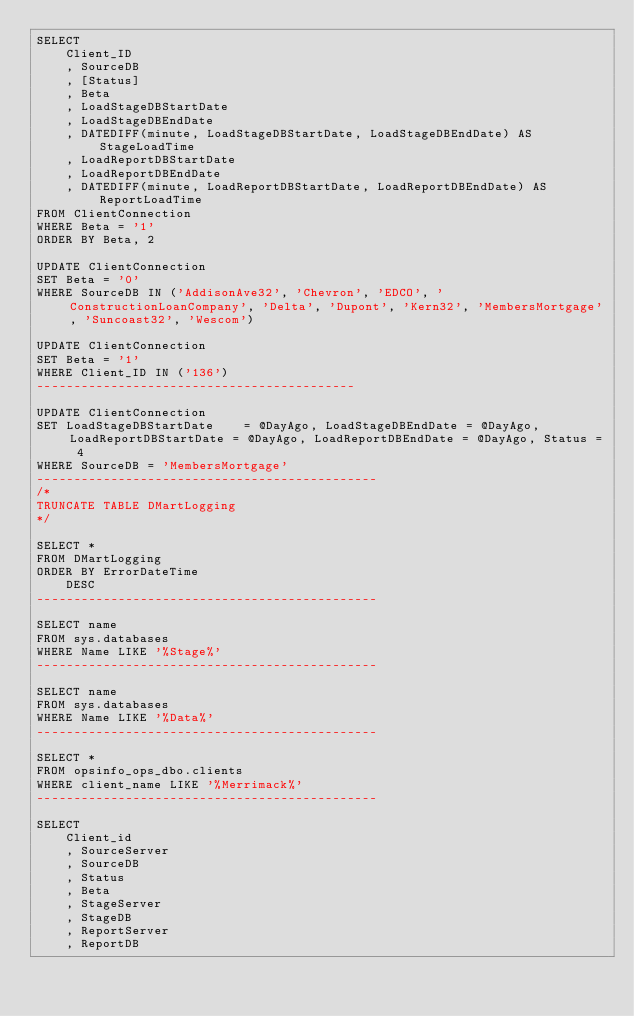Convert code to text. <code><loc_0><loc_0><loc_500><loc_500><_SQL_>SELECT
    Client_ID
    , SourceDB
    , [Status]
    , Beta
    , LoadStageDBStartDate
    , LoadStageDBEndDate
    , DATEDIFF(minute, LoadStageDBStartDate, LoadStageDBEndDate) AS StageLoadTime
    , LoadReportDBStartDate
    , LoadReportDBEndDate
    , DATEDIFF(minute, LoadReportDBStartDate, LoadReportDBEndDate) AS ReportLoadTime
FROM ClientConnection
WHERE Beta = '1'
ORDER BY Beta, 2

UPDATE ClientConnection
SET Beta = '0'
WHERE SourceDB IN ('AddisonAve32', 'Chevron', 'EDCO', 'ConstructionLoanCompany', 'Delta', 'Dupont', 'Kern32', 'MembersMortgage', 'Suncoast32', 'Wescom')

UPDATE ClientConnection
SET Beta = '1'
WHERE Client_ID IN ('136')
-------------------------------------------

UPDATE ClientConnection
SET LoadStageDBStartDate    = @DayAgo, LoadStageDBEndDate = @DayAgo, LoadReportDBStartDate = @DayAgo, LoadReportDBEndDate = @DayAgo, Status = 4
WHERE SourceDB = 'MembersMortgage'
----------------------------------------------
/*
TRUNCATE TABLE DMartLogging
*/

SELECT *
FROM DMartLogging
ORDER BY ErrorDateTime
    DESC
----------------------------------------------

SELECT name
FROM sys.databases
WHERE Name LIKE '%Stage%'
----------------------------------------------

SELECT name
FROM sys.databases
WHERE Name LIKE '%Data%'
----------------------------------------------

SELECT *
FROM opsinfo_ops_dbo.clients
WHERE client_name LIKE '%Merrimack%'
----------------------------------------------

SELECT
    Client_id
    , SourceServer
    , SourceDB
    , Status
    , Beta
    , StageServer
    , StageDB
    , ReportServer
    , ReportDB</code> 